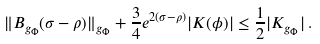<formula> <loc_0><loc_0><loc_500><loc_500>\| B _ { g _ { \Phi } } ( \sigma - \rho ) \| _ { g _ { \Phi } } + \frac { 3 } { 4 } e ^ { 2 ( \sigma - \rho ) } | K ( \phi ) | \leq \frac { 1 } { 2 } | K _ { g _ { \Phi } } | \, .</formula> 